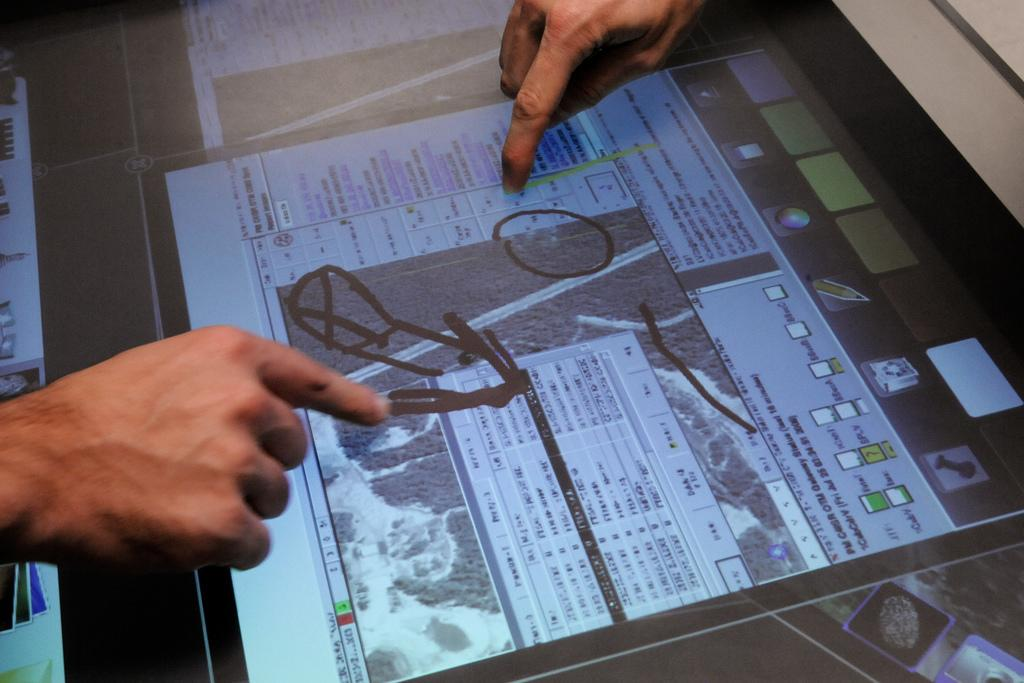What electronic device is visible in the image? There is an iPad in the image. Where is the iPad located? The iPad is on a desk. What might the hands on the iPad be doing? The hands on the iPad are presumably marking something. What type of car is the mom driving in the image? There is no car or mom present in the image; it only features an iPad on a desk with hands marking something on the screen. 